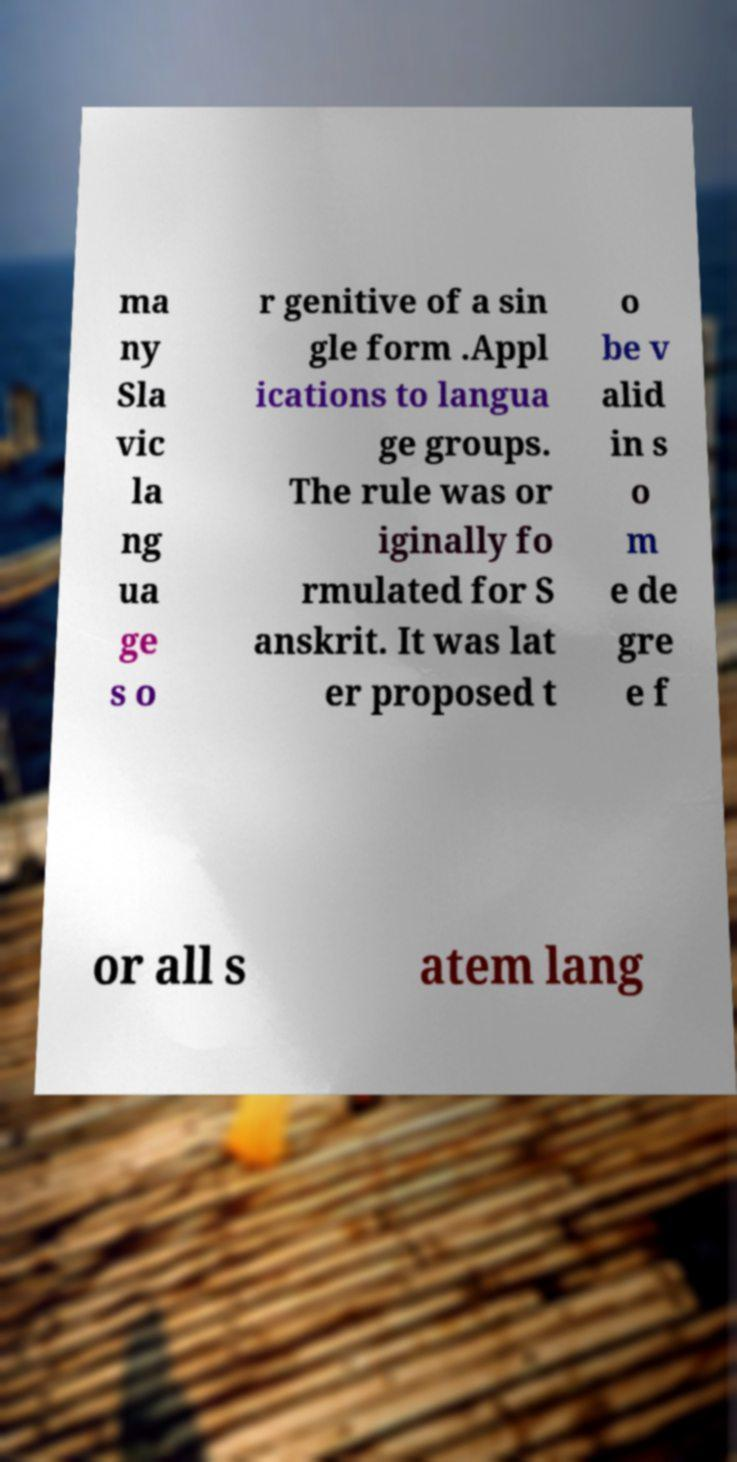Please identify and transcribe the text found in this image. ma ny Sla vic la ng ua ge s o r genitive of a sin gle form .Appl ications to langua ge groups. The rule was or iginally fo rmulated for S anskrit. It was lat er proposed t o be v alid in s o m e de gre e f or all s atem lang 